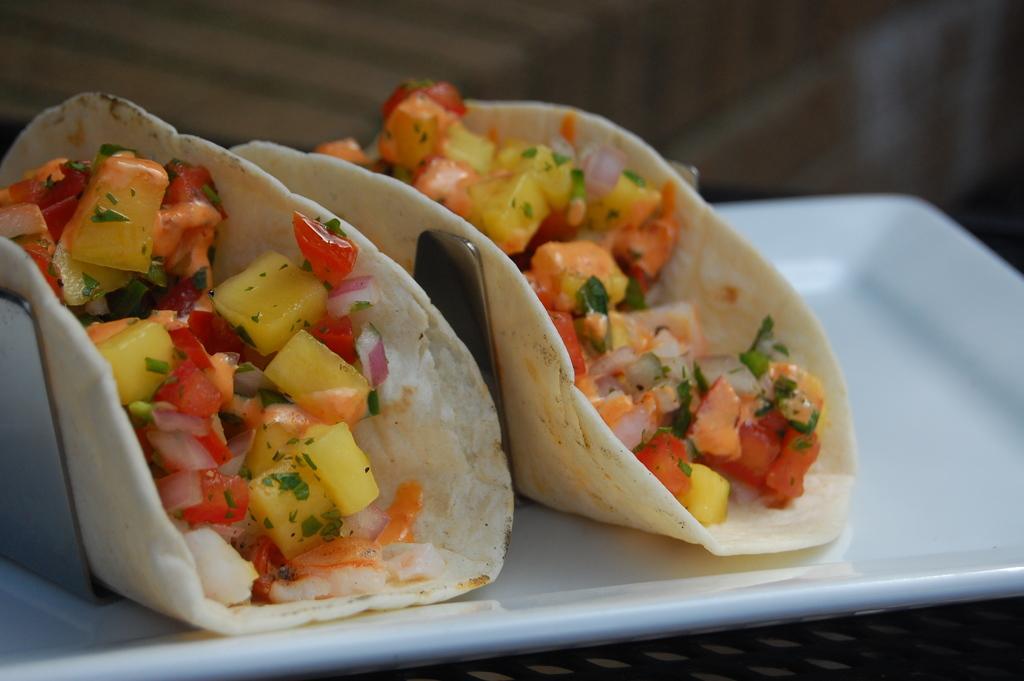Can you describe this image briefly? In this image I can see a plate which is white in color and on the plate I can see few food items which are cream, yellow, red, green and orange in color. I can see the blurry background. 